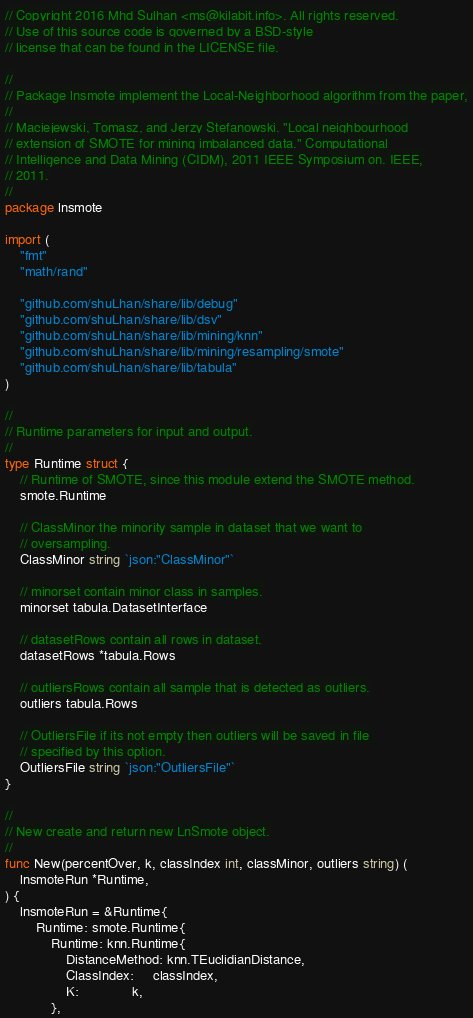<code> <loc_0><loc_0><loc_500><loc_500><_Go_>// Copyright 2016 Mhd Sulhan <ms@kilabit.info>. All rights reserved.
// Use of this source code is governed by a BSD-style
// license that can be found in the LICENSE file.

//
// Package lnsmote implement the Local-Neighborhood algorithm from the paper,
//
// Maciejewski, Tomasz, and Jerzy Stefanowski. "Local neighbourhood
// extension of SMOTE for mining imbalanced data." Computational
// Intelligence and Data Mining (CIDM), 2011 IEEE Symposium on. IEEE,
// 2011.
//
package lnsmote

import (
	"fmt"
	"math/rand"

	"github.com/shuLhan/share/lib/debug"
	"github.com/shuLhan/share/lib/dsv"
	"github.com/shuLhan/share/lib/mining/knn"
	"github.com/shuLhan/share/lib/mining/resampling/smote"
	"github.com/shuLhan/share/lib/tabula"
)

//
// Runtime parameters for input and output.
//
type Runtime struct {
	// Runtime of SMOTE, since this module extend the SMOTE method.
	smote.Runtime

	// ClassMinor the minority sample in dataset that we want to
	// oversampling.
	ClassMinor string `json:"ClassMinor"`

	// minorset contain minor class in samples.
	minorset tabula.DatasetInterface

	// datasetRows contain all rows in dataset.
	datasetRows *tabula.Rows

	// outliersRows contain all sample that is detected as outliers.
	outliers tabula.Rows

	// OutliersFile if its not empty then outliers will be saved in file
	// specified by this option.
	OutliersFile string `json:"OutliersFile"`
}

//
// New create and return new LnSmote object.
//
func New(percentOver, k, classIndex int, classMinor, outliers string) (
	lnsmoteRun *Runtime,
) {
	lnsmoteRun = &Runtime{
		Runtime: smote.Runtime{
			Runtime: knn.Runtime{
				DistanceMethod: knn.TEuclidianDistance,
				ClassIndex:     classIndex,
				K:              k,
			},</code> 